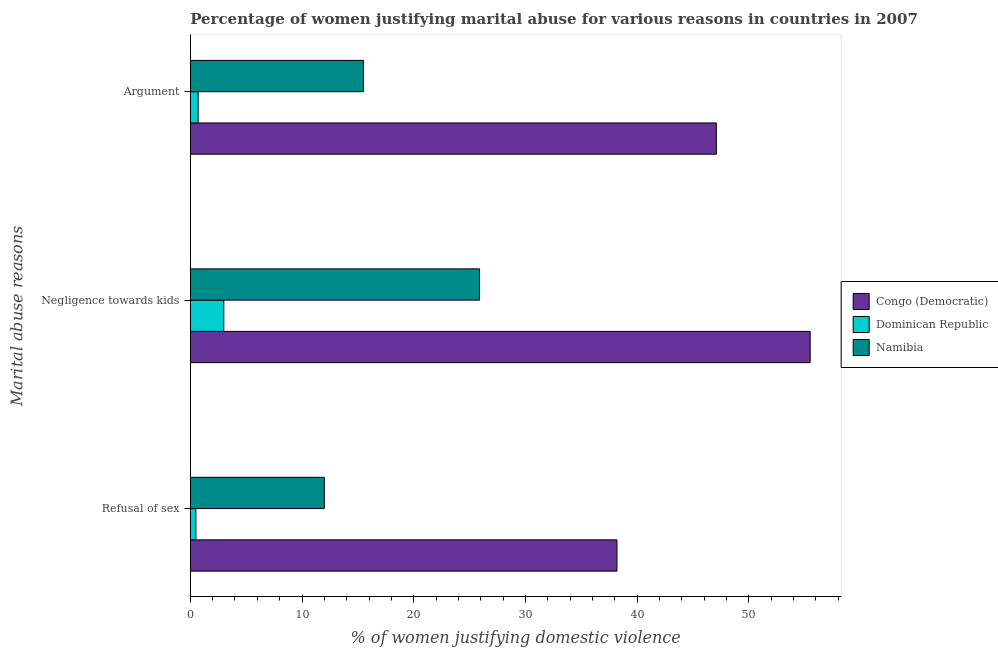How many different coloured bars are there?
Keep it short and to the point. 3. What is the label of the 3rd group of bars from the top?
Your answer should be compact. Refusal of sex. What is the percentage of women justifying domestic violence due to refusal of sex in Congo (Democratic)?
Your response must be concise. 38.2. Across all countries, what is the maximum percentage of women justifying domestic violence due to refusal of sex?
Offer a terse response. 38.2. In which country was the percentage of women justifying domestic violence due to negligence towards kids maximum?
Ensure brevity in your answer.  Congo (Democratic). In which country was the percentage of women justifying domestic violence due to negligence towards kids minimum?
Give a very brief answer. Dominican Republic. What is the total percentage of women justifying domestic violence due to negligence towards kids in the graph?
Offer a very short reply. 84.4. What is the difference between the percentage of women justifying domestic violence due to negligence towards kids in Congo (Democratic) and that in Namibia?
Keep it short and to the point. 29.6. What is the average percentage of women justifying domestic violence due to arguments per country?
Your answer should be very brief. 21.1. What is the difference between the percentage of women justifying domestic violence due to negligence towards kids and percentage of women justifying domestic violence due to refusal of sex in Congo (Democratic)?
Keep it short and to the point. 17.3. In how many countries, is the percentage of women justifying domestic violence due to negligence towards kids greater than 18 %?
Keep it short and to the point. 2. Is the percentage of women justifying domestic violence due to refusal of sex in Congo (Democratic) less than that in Dominican Republic?
Ensure brevity in your answer.  No. Is the difference between the percentage of women justifying domestic violence due to arguments in Dominican Republic and Namibia greater than the difference between the percentage of women justifying domestic violence due to refusal of sex in Dominican Republic and Namibia?
Make the answer very short. No. What is the difference between the highest and the second highest percentage of women justifying domestic violence due to arguments?
Offer a terse response. 31.6. What is the difference between the highest and the lowest percentage of women justifying domestic violence due to refusal of sex?
Offer a very short reply. 37.7. In how many countries, is the percentage of women justifying domestic violence due to refusal of sex greater than the average percentage of women justifying domestic violence due to refusal of sex taken over all countries?
Offer a terse response. 1. What does the 1st bar from the top in Argument represents?
Provide a short and direct response. Namibia. What does the 3rd bar from the bottom in Refusal of sex represents?
Offer a terse response. Namibia. How many countries are there in the graph?
Give a very brief answer. 3. What is the difference between two consecutive major ticks on the X-axis?
Provide a succinct answer. 10. Does the graph contain grids?
Provide a succinct answer. No. Where does the legend appear in the graph?
Offer a terse response. Center right. What is the title of the graph?
Offer a terse response. Percentage of women justifying marital abuse for various reasons in countries in 2007. Does "Middle East & North Africa (all income levels)" appear as one of the legend labels in the graph?
Your answer should be very brief. No. What is the label or title of the X-axis?
Ensure brevity in your answer.  % of women justifying domestic violence. What is the label or title of the Y-axis?
Provide a succinct answer. Marital abuse reasons. What is the % of women justifying domestic violence of Congo (Democratic) in Refusal of sex?
Provide a short and direct response. 38.2. What is the % of women justifying domestic violence of Dominican Republic in Refusal of sex?
Provide a short and direct response. 0.5. What is the % of women justifying domestic violence in Congo (Democratic) in Negligence towards kids?
Ensure brevity in your answer.  55.5. What is the % of women justifying domestic violence in Dominican Republic in Negligence towards kids?
Your answer should be compact. 3. What is the % of women justifying domestic violence in Namibia in Negligence towards kids?
Make the answer very short. 25.9. What is the % of women justifying domestic violence of Congo (Democratic) in Argument?
Make the answer very short. 47.1. Across all Marital abuse reasons, what is the maximum % of women justifying domestic violence of Congo (Democratic)?
Ensure brevity in your answer.  55.5. Across all Marital abuse reasons, what is the maximum % of women justifying domestic violence in Namibia?
Give a very brief answer. 25.9. Across all Marital abuse reasons, what is the minimum % of women justifying domestic violence of Congo (Democratic)?
Your answer should be compact. 38.2. Across all Marital abuse reasons, what is the minimum % of women justifying domestic violence of Dominican Republic?
Your response must be concise. 0.5. Across all Marital abuse reasons, what is the minimum % of women justifying domestic violence in Namibia?
Your answer should be compact. 12. What is the total % of women justifying domestic violence in Congo (Democratic) in the graph?
Offer a terse response. 140.8. What is the total % of women justifying domestic violence of Namibia in the graph?
Ensure brevity in your answer.  53.4. What is the difference between the % of women justifying domestic violence of Congo (Democratic) in Refusal of sex and that in Negligence towards kids?
Provide a succinct answer. -17.3. What is the difference between the % of women justifying domestic violence in Namibia in Refusal of sex and that in Negligence towards kids?
Make the answer very short. -13.9. What is the difference between the % of women justifying domestic violence in Namibia in Refusal of sex and that in Argument?
Your answer should be very brief. -3.5. What is the difference between the % of women justifying domestic violence in Congo (Democratic) in Negligence towards kids and that in Argument?
Your response must be concise. 8.4. What is the difference between the % of women justifying domestic violence of Dominican Republic in Negligence towards kids and that in Argument?
Your answer should be very brief. 2.3. What is the difference between the % of women justifying domestic violence of Namibia in Negligence towards kids and that in Argument?
Make the answer very short. 10.4. What is the difference between the % of women justifying domestic violence in Congo (Democratic) in Refusal of sex and the % of women justifying domestic violence in Dominican Republic in Negligence towards kids?
Make the answer very short. 35.2. What is the difference between the % of women justifying domestic violence of Congo (Democratic) in Refusal of sex and the % of women justifying domestic violence of Namibia in Negligence towards kids?
Keep it short and to the point. 12.3. What is the difference between the % of women justifying domestic violence of Dominican Republic in Refusal of sex and the % of women justifying domestic violence of Namibia in Negligence towards kids?
Offer a terse response. -25.4. What is the difference between the % of women justifying domestic violence of Congo (Democratic) in Refusal of sex and the % of women justifying domestic violence of Dominican Republic in Argument?
Offer a very short reply. 37.5. What is the difference between the % of women justifying domestic violence in Congo (Democratic) in Refusal of sex and the % of women justifying domestic violence in Namibia in Argument?
Provide a succinct answer. 22.7. What is the difference between the % of women justifying domestic violence in Congo (Democratic) in Negligence towards kids and the % of women justifying domestic violence in Dominican Republic in Argument?
Offer a very short reply. 54.8. What is the average % of women justifying domestic violence of Congo (Democratic) per Marital abuse reasons?
Provide a short and direct response. 46.93. What is the average % of women justifying domestic violence of Dominican Republic per Marital abuse reasons?
Make the answer very short. 1.4. What is the average % of women justifying domestic violence of Namibia per Marital abuse reasons?
Provide a short and direct response. 17.8. What is the difference between the % of women justifying domestic violence of Congo (Democratic) and % of women justifying domestic violence of Dominican Republic in Refusal of sex?
Provide a succinct answer. 37.7. What is the difference between the % of women justifying domestic violence of Congo (Democratic) and % of women justifying domestic violence of Namibia in Refusal of sex?
Make the answer very short. 26.2. What is the difference between the % of women justifying domestic violence in Congo (Democratic) and % of women justifying domestic violence in Dominican Republic in Negligence towards kids?
Offer a very short reply. 52.5. What is the difference between the % of women justifying domestic violence in Congo (Democratic) and % of women justifying domestic violence in Namibia in Negligence towards kids?
Provide a short and direct response. 29.6. What is the difference between the % of women justifying domestic violence in Dominican Republic and % of women justifying domestic violence in Namibia in Negligence towards kids?
Provide a short and direct response. -22.9. What is the difference between the % of women justifying domestic violence in Congo (Democratic) and % of women justifying domestic violence in Dominican Republic in Argument?
Offer a very short reply. 46.4. What is the difference between the % of women justifying domestic violence of Congo (Democratic) and % of women justifying domestic violence of Namibia in Argument?
Provide a short and direct response. 31.6. What is the difference between the % of women justifying domestic violence in Dominican Republic and % of women justifying domestic violence in Namibia in Argument?
Your answer should be compact. -14.8. What is the ratio of the % of women justifying domestic violence in Congo (Democratic) in Refusal of sex to that in Negligence towards kids?
Ensure brevity in your answer.  0.69. What is the ratio of the % of women justifying domestic violence of Namibia in Refusal of sex to that in Negligence towards kids?
Give a very brief answer. 0.46. What is the ratio of the % of women justifying domestic violence of Congo (Democratic) in Refusal of sex to that in Argument?
Ensure brevity in your answer.  0.81. What is the ratio of the % of women justifying domestic violence of Namibia in Refusal of sex to that in Argument?
Ensure brevity in your answer.  0.77. What is the ratio of the % of women justifying domestic violence of Congo (Democratic) in Negligence towards kids to that in Argument?
Your answer should be very brief. 1.18. What is the ratio of the % of women justifying domestic violence of Dominican Republic in Negligence towards kids to that in Argument?
Offer a very short reply. 4.29. What is the ratio of the % of women justifying domestic violence in Namibia in Negligence towards kids to that in Argument?
Provide a short and direct response. 1.67. What is the difference between the highest and the second highest % of women justifying domestic violence of Dominican Republic?
Offer a very short reply. 2.3. 